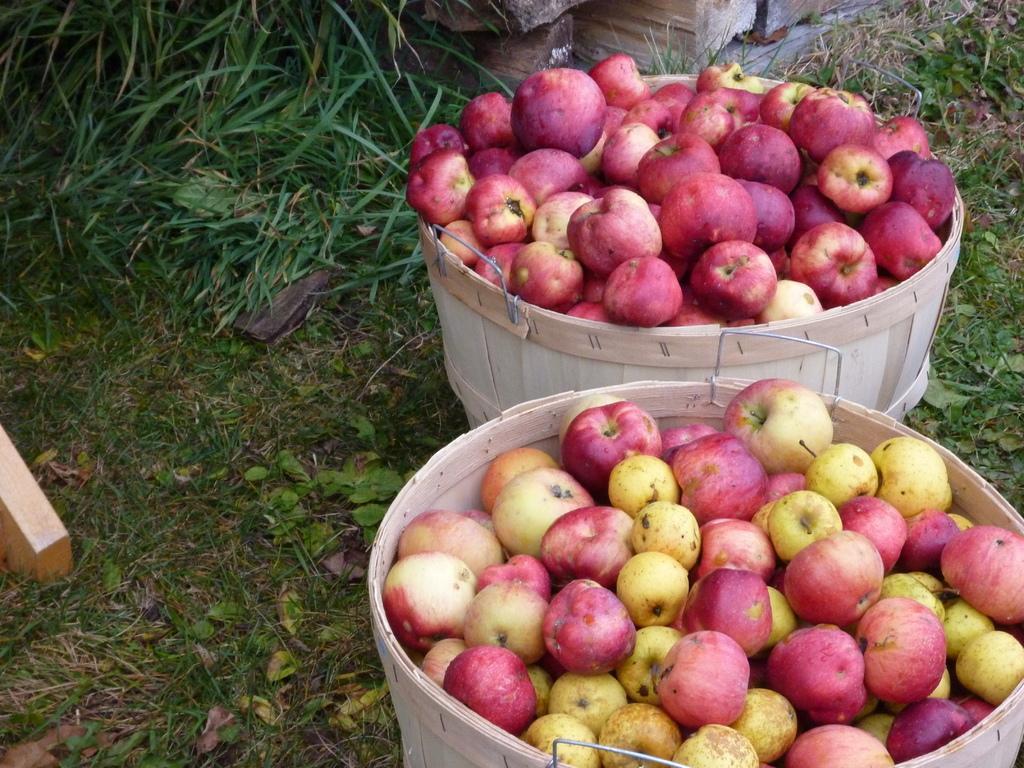How would you summarize this image in a sentence or two? This image consists of many apples kept in the baskets. At the bottom, there is green grass. In the background, we can see the wooden sticks. 